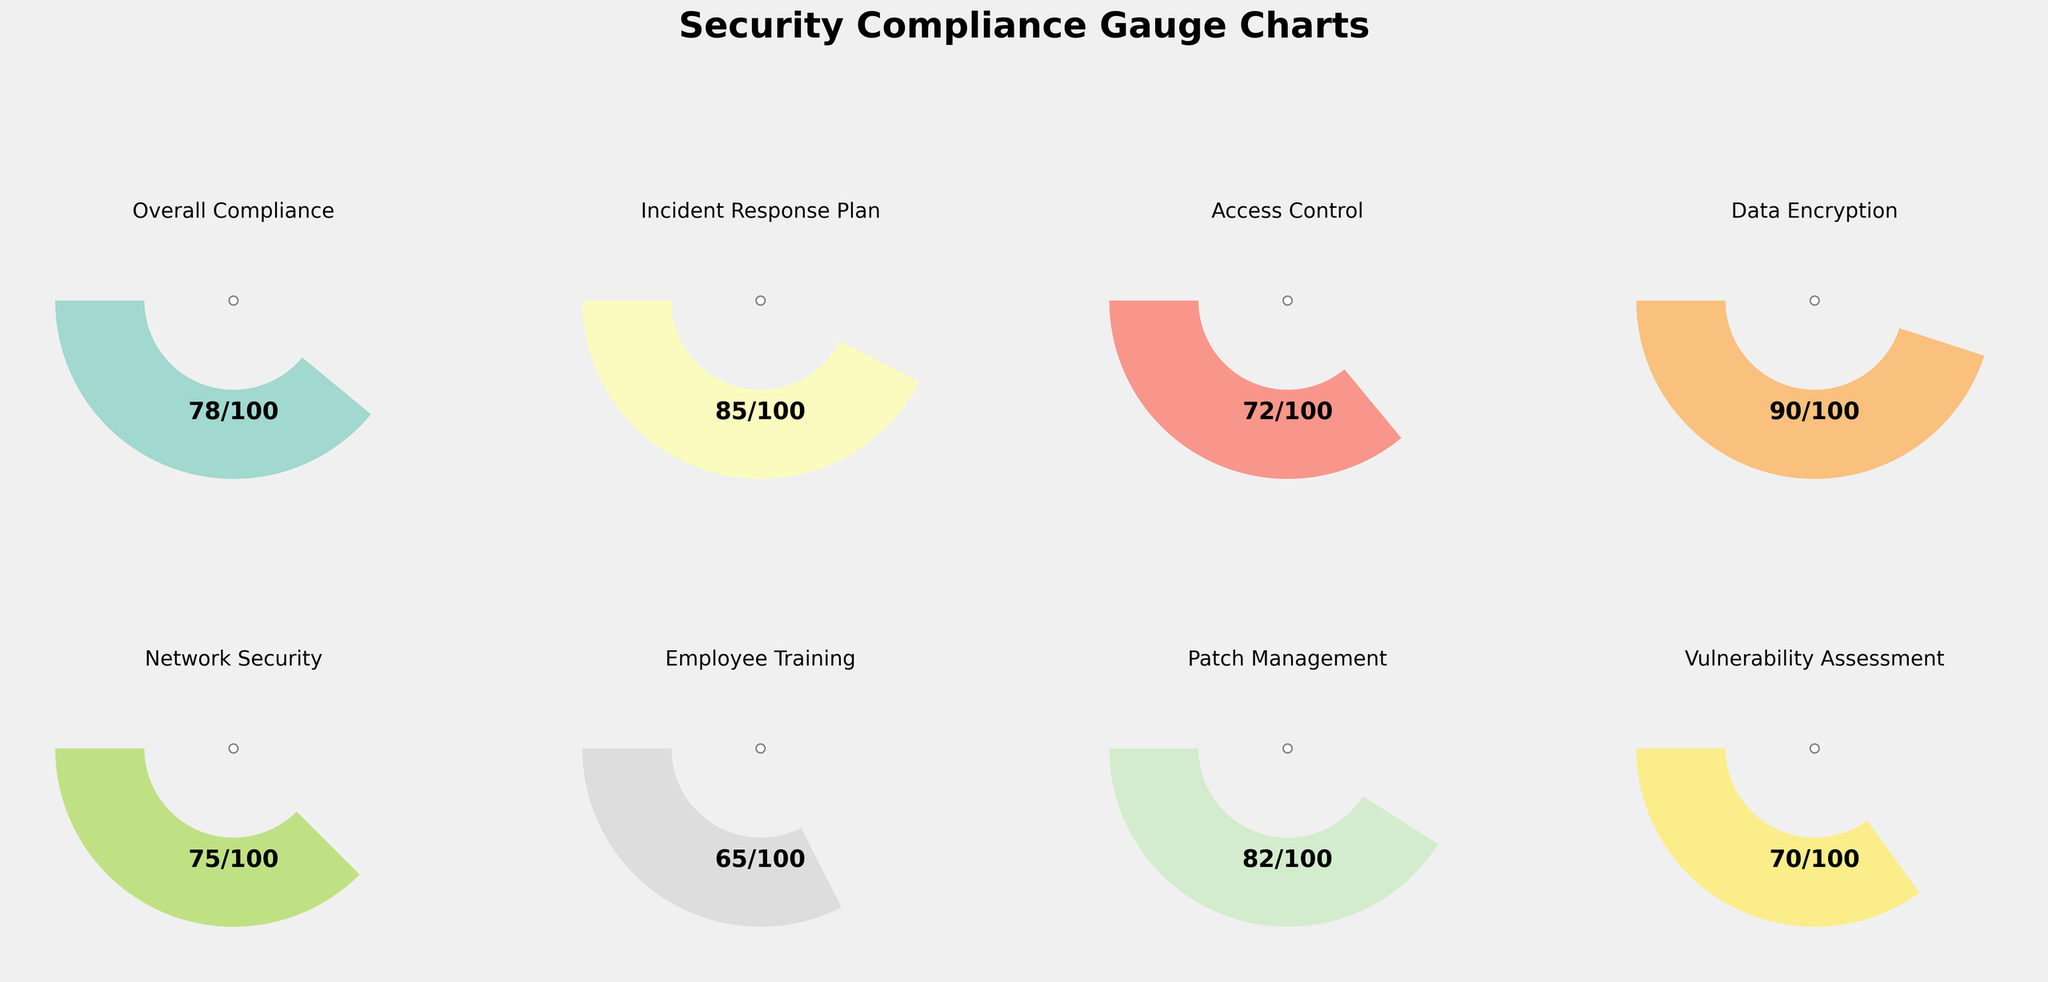What is the highest compliance score among the categories? Refer to each individual gauge chart to find the highest score value. The highest compliance score is for Data Encryption with a score of 90.
Answer: 90 Which category has the lowest compliance score? Observe each gauge chart for the minimum score value. Employee Training has the lowest compliance score with a score of 65.
Answer: Employee Training What is the overall compliance score? Check the gauge labeled "Overall Compliance" to find its score. The overall compliance score is 78.
Answer: 78 What is the difference between the compliance score of Access Control and Network Security? Subtract the compliance score of Network Security from the compliance score of Access Control. Access Control has a score of 72 and Network Security has a score of 75, so 72 - 75 = -3.
Answer: -3 Which categories have scores above 80? Identify all gauge charts with scores higher than 80. The categories with scores above 80 are Data Encryption, Incident Response Plan, and Patch Management.
Answer: Data Encryption, Incident Response Plan, Patch Management How does the score of Vulnerability Assessment compare to Incident Response Plan? Compare the compliance scores of Vulnerability Assessment and Incident Response Plan. Incident Response Plan has a score of 85 while Vulnerability Assessment has a score of 70, so Incident Response Plan's score is higher.
Answer: Incident Response Plan has a higher score What is the average compliance score across all categories? Sum all the compliance scores and divide by the number of categories. The scores are 78, 85, 72, 90, 75, 65, 82, and 70. The sum is 617. Dividing by 8 categories, the average score is 77.125.
Answer: 77.125 What percentage of the maximum score has Employee Training achieved? Divide Employee Training’s score by its maximum score and multiply by 100. Employee Training’s score is 65, and its maximum score is 100, so (65/100) * 100 = 65%.
Answer: 65% Which categories have a score within 5 points of the overall compliance score? Check the scores that fall within the range 78 ± 5 (i.e., between 73 and 83). The categories are Patch Management (82) and Network Security (75).
Answer: Patch Management, Network Security What is the total number of categories displayed in the gauge charts? Count the number of individual gauge charts shown in the plot. There are 8 gauge charts representing different categories.
Answer: 8 